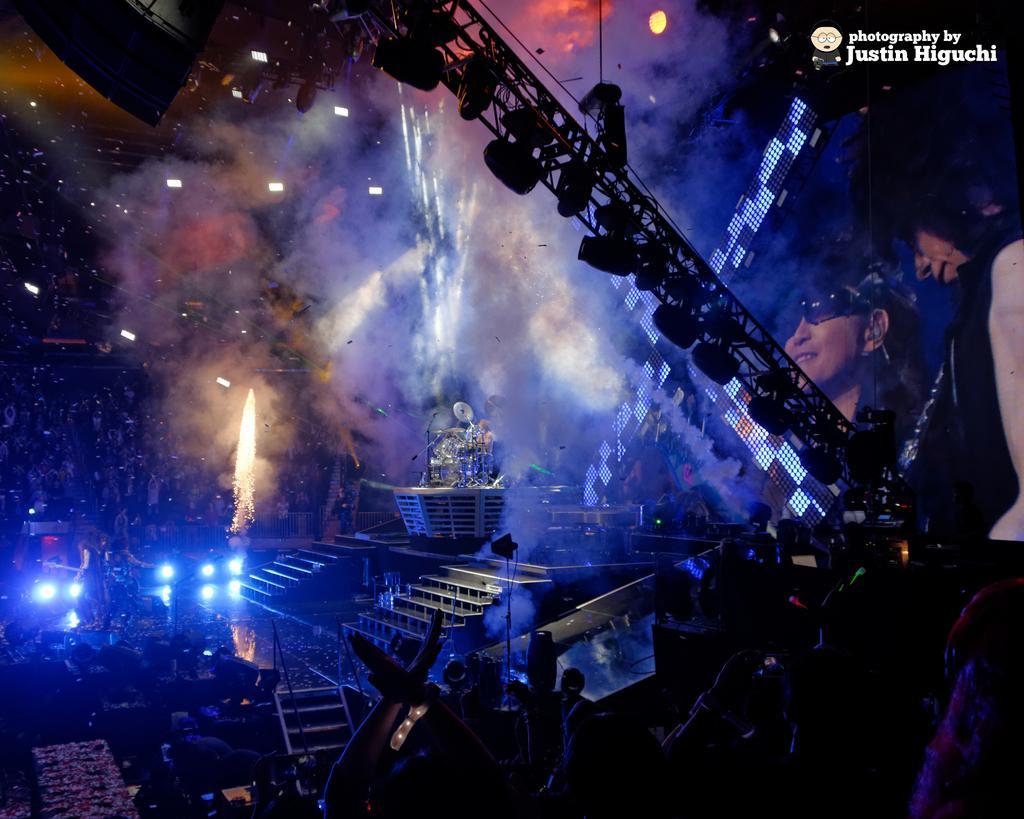Please provide a concise description of this image. In this image there are focus lights, lighting truss, screen ,group of people, a person playing the drums on the stage , and there is a watermark on the image. 